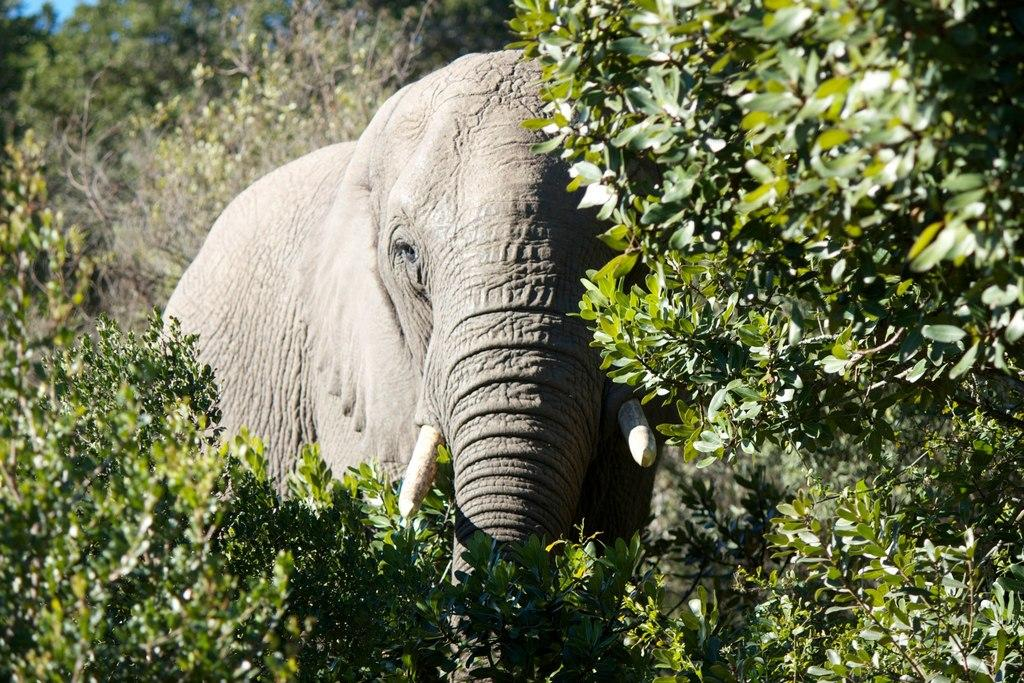What animal is the main subject of the picture? There is an elephant in the picture. What is the elephant doing in the picture? The elephant is standing. What can be seen in the background of the picture? There are trees visible in the background of the picture. What is visible at the top of the picture? The sky is visible at the top of the picture. How many mice are hiding behind the elephant in the picture? There are no mice present in the image; it features an elephant standing in front of trees with the sky visible at the top. 